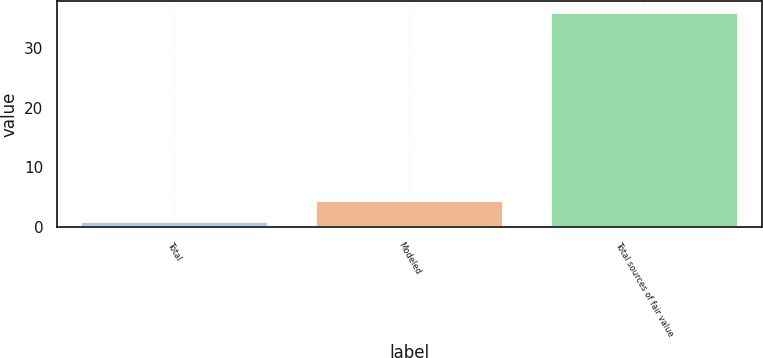<chart> <loc_0><loc_0><loc_500><loc_500><bar_chart><fcel>Total<fcel>Modeled<fcel>Total sources of fair value<nl><fcel>1<fcel>4.5<fcel>36<nl></chart> 